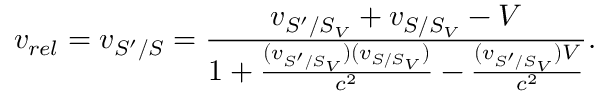<formula> <loc_0><loc_0><loc_500><loc_500>v _ { r e l } = v _ { S ^ { \prime } / S } = \frac { v _ { S ^ { \prime } / S _ { V } } + v _ { S / S _ { V } } - V } { 1 + \frac { ( v _ { S ^ { \prime } / S _ { V } } ) ( v _ { S / S _ { V } } ) } { c ^ { 2 } } - \frac { ( v _ { S ^ { \prime } / S _ { V } } ) V } { c ^ { 2 } } } .</formula> 